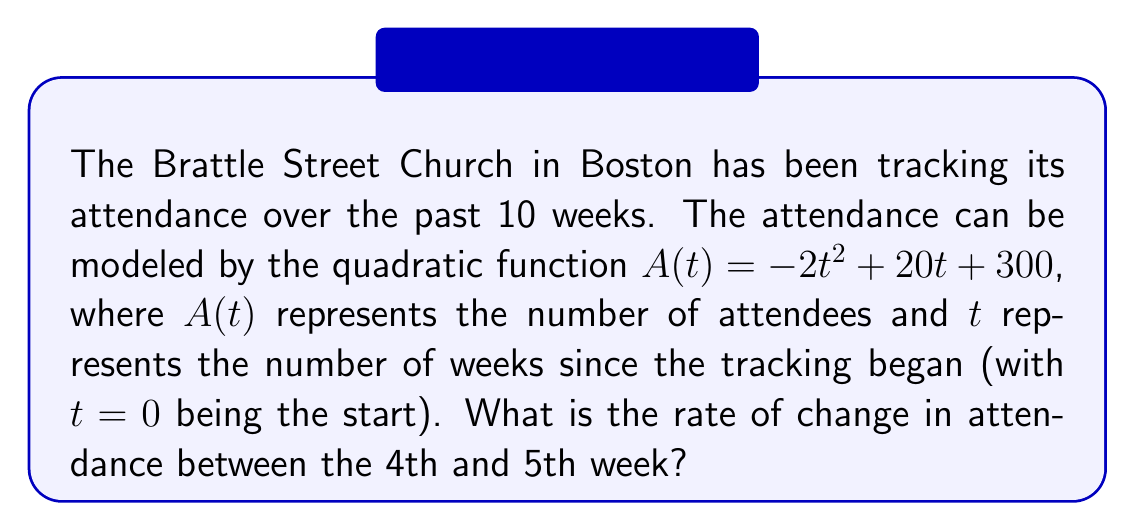Help me with this question. To solve this problem, we need to follow these steps:

1) The rate of change between two points is given by the average rate of change formula:

   $$\text{Rate of change} = \frac{A(t_2) - A(t_1)}{t_2 - t_1}$$

   where $t_1 = 4$ and $t_2 = 5$ in this case.

2) Let's calculate $A(4)$ and $A(5)$:

   $A(4) = -2(4)^2 + 20(4) + 300 = -32 + 80 + 300 = 348$

   $A(5) = -2(5)^2 + 20(5) + 300 = -50 + 100 + 300 = 350$

3) Now we can substitute these values into our rate of change formula:

   $$\text{Rate of change} = \frac{A(5) - A(4)}{5 - 4} = \frac{350 - 348}{1} = 2$$

4) Therefore, the rate of change in attendance between the 4th and 5th week is 2 people per week.

Note: This positive rate of change indicates that attendance is still increasing between these weeks, although the quadratic nature of the function means this increase will eventually slow and reverse.
Answer: 2 people per week 